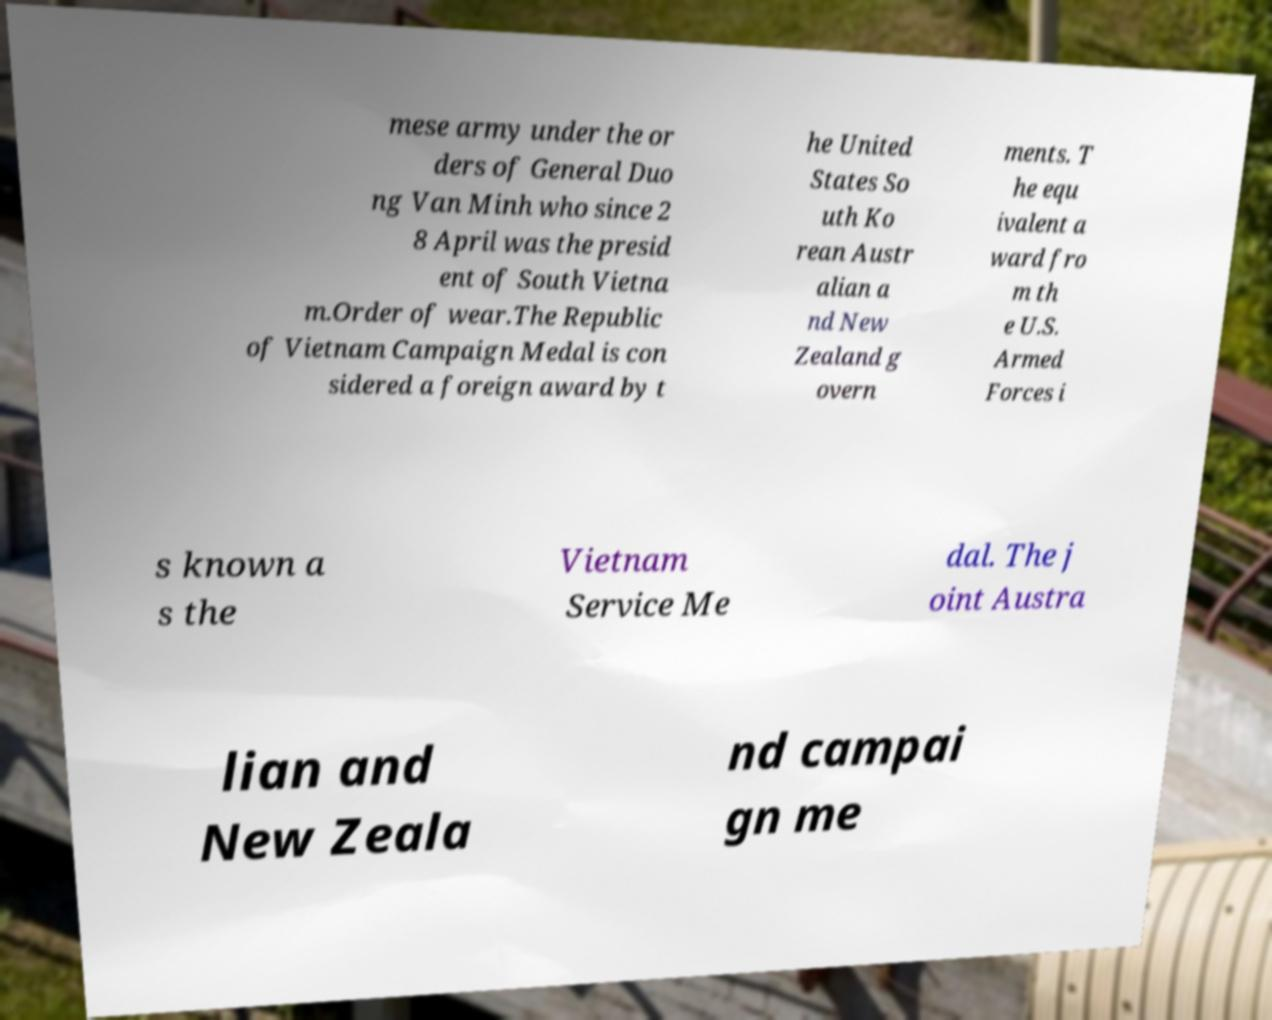Could you extract and type out the text from this image? mese army under the or ders of General Duo ng Van Minh who since 2 8 April was the presid ent of South Vietna m.Order of wear.The Republic of Vietnam Campaign Medal is con sidered a foreign award by t he United States So uth Ko rean Austr alian a nd New Zealand g overn ments. T he equ ivalent a ward fro m th e U.S. Armed Forces i s known a s the Vietnam Service Me dal. The j oint Austra lian and New Zeala nd campai gn me 